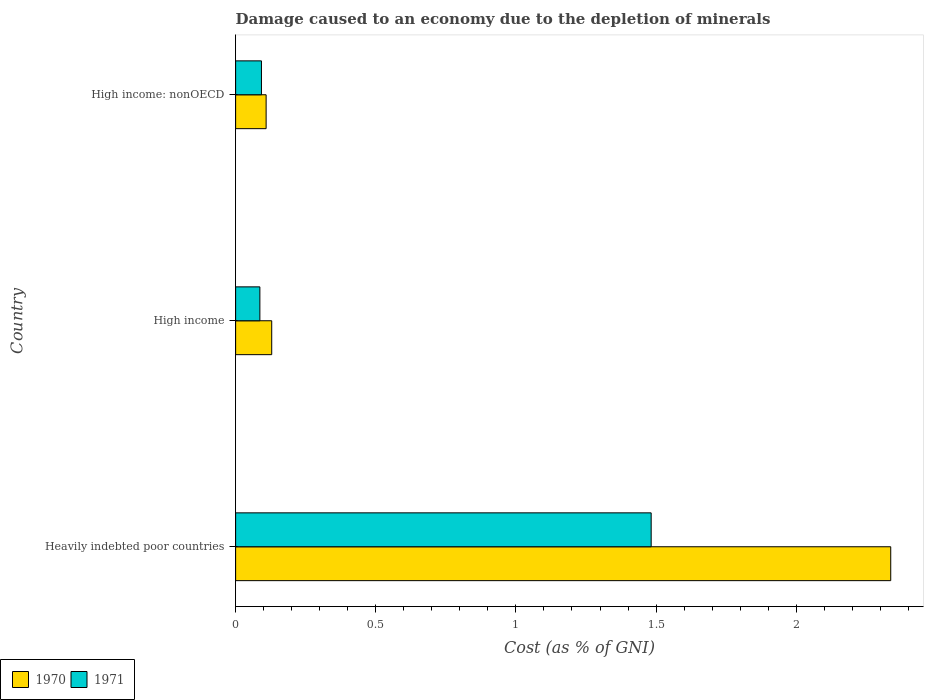How many different coloured bars are there?
Your response must be concise. 2. How many groups of bars are there?
Ensure brevity in your answer.  3. Are the number of bars per tick equal to the number of legend labels?
Your answer should be very brief. Yes. Are the number of bars on each tick of the Y-axis equal?
Keep it short and to the point. Yes. How many bars are there on the 3rd tick from the bottom?
Make the answer very short. 2. What is the label of the 3rd group of bars from the top?
Ensure brevity in your answer.  Heavily indebted poor countries. In how many cases, is the number of bars for a given country not equal to the number of legend labels?
Provide a short and direct response. 0. What is the cost of damage caused due to the depletion of minerals in 1970 in High income?
Provide a succinct answer. 0.13. Across all countries, what is the maximum cost of damage caused due to the depletion of minerals in 1970?
Offer a very short reply. 2.34. Across all countries, what is the minimum cost of damage caused due to the depletion of minerals in 1971?
Offer a terse response. 0.09. In which country was the cost of damage caused due to the depletion of minerals in 1970 maximum?
Make the answer very short. Heavily indebted poor countries. In which country was the cost of damage caused due to the depletion of minerals in 1970 minimum?
Give a very brief answer. High income: nonOECD. What is the total cost of damage caused due to the depletion of minerals in 1971 in the graph?
Your answer should be compact. 1.66. What is the difference between the cost of damage caused due to the depletion of minerals in 1970 in Heavily indebted poor countries and that in High income?
Your answer should be very brief. 2.21. What is the difference between the cost of damage caused due to the depletion of minerals in 1970 in High income: nonOECD and the cost of damage caused due to the depletion of minerals in 1971 in High income?
Provide a short and direct response. 0.02. What is the average cost of damage caused due to the depletion of minerals in 1970 per country?
Offer a very short reply. 0.86. What is the difference between the cost of damage caused due to the depletion of minerals in 1971 and cost of damage caused due to the depletion of minerals in 1970 in High income: nonOECD?
Ensure brevity in your answer.  -0.02. What is the ratio of the cost of damage caused due to the depletion of minerals in 1971 in Heavily indebted poor countries to that in High income: nonOECD?
Offer a terse response. 16.08. Is the cost of damage caused due to the depletion of minerals in 1971 in High income less than that in High income: nonOECD?
Provide a short and direct response. Yes. Is the difference between the cost of damage caused due to the depletion of minerals in 1971 in Heavily indebted poor countries and High income: nonOECD greater than the difference between the cost of damage caused due to the depletion of minerals in 1970 in Heavily indebted poor countries and High income: nonOECD?
Make the answer very short. No. What is the difference between the highest and the second highest cost of damage caused due to the depletion of minerals in 1971?
Offer a very short reply. 1.39. What is the difference between the highest and the lowest cost of damage caused due to the depletion of minerals in 1970?
Make the answer very short. 2.23. In how many countries, is the cost of damage caused due to the depletion of minerals in 1971 greater than the average cost of damage caused due to the depletion of minerals in 1971 taken over all countries?
Your answer should be very brief. 1. Where does the legend appear in the graph?
Provide a short and direct response. Bottom left. How many legend labels are there?
Give a very brief answer. 2. How are the legend labels stacked?
Your answer should be very brief. Horizontal. What is the title of the graph?
Make the answer very short. Damage caused to an economy due to the depletion of minerals. What is the label or title of the X-axis?
Keep it short and to the point. Cost (as % of GNI). What is the Cost (as % of GNI) of 1970 in Heavily indebted poor countries?
Your response must be concise. 2.34. What is the Cost (as % of GNI) of 1971 in Heavily indebted poor countries?
Your answer should be very brief. 1.48. What is the Cost (as % of GNI) in 1970 in High income?
Ensure brevity in your answer.  0.13. What is the Cost (as % of GNI) of 1971 in High income?
Your answer should be very brief. 0.09. What is the Cost (as % of GNI) of 1970 in High income: nonOECD?
Give a very brief answer. 0.11. What is the Cost (as % of GNI) in 1971 in High income: nonOECD?
Offer a terse response. 0.09. Across all countries, what is the maximum Cost (as % of GNI) of 1970?
Ensure brevity in your answer.  2.34. Across all countries, what is the maximum Cost (as % of GNI) in 1971?
Provide a short and direct response. 1.48. Across all countries, what is the minimum Cost (as % of GNI) of 1970?
Keep it short and to the point. 0.11. Across all countries, what is the minimum Cost (as % of GNI) in 1971?
Ensure brevity in your answer.  0.09. What is the total Cost (as % of GNI) in 1970 in the graph?
Give a very brief answer. 2.57. What is the total Cost (as % of GNI) of 1971 in the graph?
Your answer should be very brief. 1.66. What is the difference between the Cost (as % of GNI) in 1970 in Heavily indebted poor countries and that in High income?
Make the answer very short. 2.21. What is the difference between the Cost (as % of GNI) in 1971 in Heavily indebted poor countries and that in High income?
Ensure brevity in your answer.  1.4. What is the difference between the Cost (as % of GNI) in 1970 in Heavily indebted poor countries and that in High income: nonOECD?
Keep it short and to the point. 2.23. What is the difference between the Cost (as % of GNI) of 1971 in Heavily indebted poor countries and that in High income: nonOECD?
Your response must be concise. 1.39. What is the difference between the Cost (as % of GNI) of 1970 in High income and that in High income: nonOECD?
Offer a very short reply. 0.02. What is the difference between the Cost (as % of GNI) of 1971 in High income and that in High income: nonOECD?
Your answer should be very brief. -0.01. What is the difference between the Cost (as % of GNI) in 1970 in Heavily indebted poor countries and the Cost (as % of GNI) in 1971 in High income?
Make the answer very short. 2.25. What is the difference between the Cost (as % of GNI) in 1970 in Heavily indebted poor countries and the Cost (as % of GNI) in 1971 in High income: nonOECD?
Offer a terse response. 2.25. What is the difference between the Cost (as % of GNI) in 1970 in High income and the Cost (as % of GNI) in 1971 in High income: nonOECD?
Your answer should be compact. 0.04. What is the average Cost (as % of GNI) of 1970 per country?
Your response must be concise. 0.86. What is the average Cost (as % of GNI) of 1971 per country?
Offer a very short reply. 0.55. What is the difference between the Cost (as % of GNI) in 1970 and Cost (as % of GNI) in 1971 in Heavily indebted poor countries?
Give a very brief answer. 0.85. What is the difference between the Cost (as % of GNI) in 1970 and Cost (as % of GNI) in 1971 in High income?
Give a very brief answer. 0.04. What is the difference between the Cost (as % of GNI) of 1970 and Cost (as % of GNI) of 1971 in High income: nonOECD?
Give a very brief answer. 0.02. What is the ratio of the Cost (as % of GNI) in 1970 in Heavily indebted poor countries to that in High income?
Provide a succinct answer. 18.15. What is the ratio of the Cost (as % of GNI) of 1971 in Heavily indebted poor countries to that in High income?
Make the answer very short. 17.13. What is the ratio of the Cost (as % of GNI) in 1970 in Heavily indebted poor countries to that in High income: nonOECD?
Your answer should be very brief. 21.48. What is the ratio of the Cost (as % of GNI) of 1971 in Heavily indebted poor countries to that in High income: nonOECD?
Your answer should be compact. 16.08. What is the ratio of the Cost (as % of GNI) of 1970 in High income to that in High income: nonOECD?
Keep it short and to the point. 1.18. What is the ratio of the Cost (as % of GNI) in 1971 in High income to that in High income: nonOECD?
Your answer should be very brief. 0.94. What is the difference between the highest and the second highest Cost (as % of GNI) in 1970?
Your answer should be very brief. 2.21. What is the difference between the highest and the second highest Cost (as % of GNI) in 1971?
Your response must be concise. 1.39. What is the difference between the highest and the lowest Cost (as % of GNI) in 1970?
Offer a very short reply. 2.23. What is the difference between the highest and the lowest Cost (as % of GNI) of 1971?
Your answer should be very brief. 1.4. 